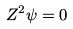Convert formula to latex. <formula><loc_0><loc_0><loc_500><loc_500>Z ^ { 2 } \psi = 0</formula> 